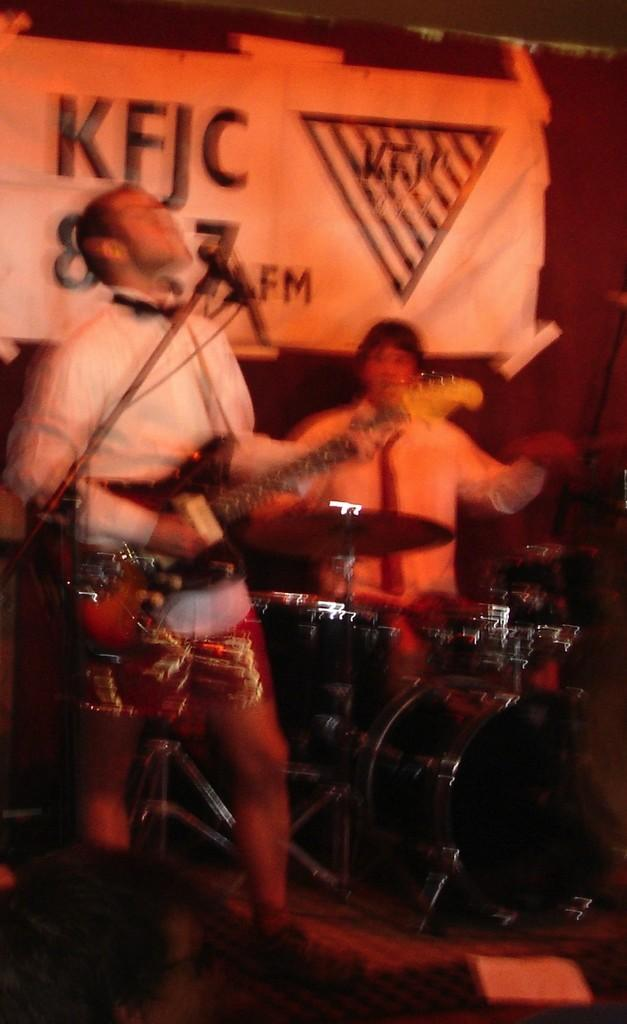How many people are in the image? There are two persons in the image. What is one person holding in the image? One person is holding a guitar. Where is the person with the guitar positioned in relation to the mic? The person with the guitar is in front of a mic. What other musical instrument can be seen in the image? There are drums in the image. What is present in the background of the image? There is a banner in the background of the image. Can you see the sea in the background of the image? No, the sea is not present in the background of the image; there is a banner instead. What type of tray is being used by the person with the guitar? There is no tray visible in the image; the person is holding a guitar. 